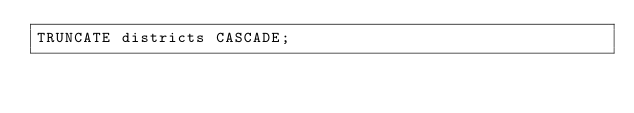Convert code to text. <code><loc_0><loc_0><loc_500><loc_500><_SQL_>TRUNCATE districts CASCADE;
</code> 